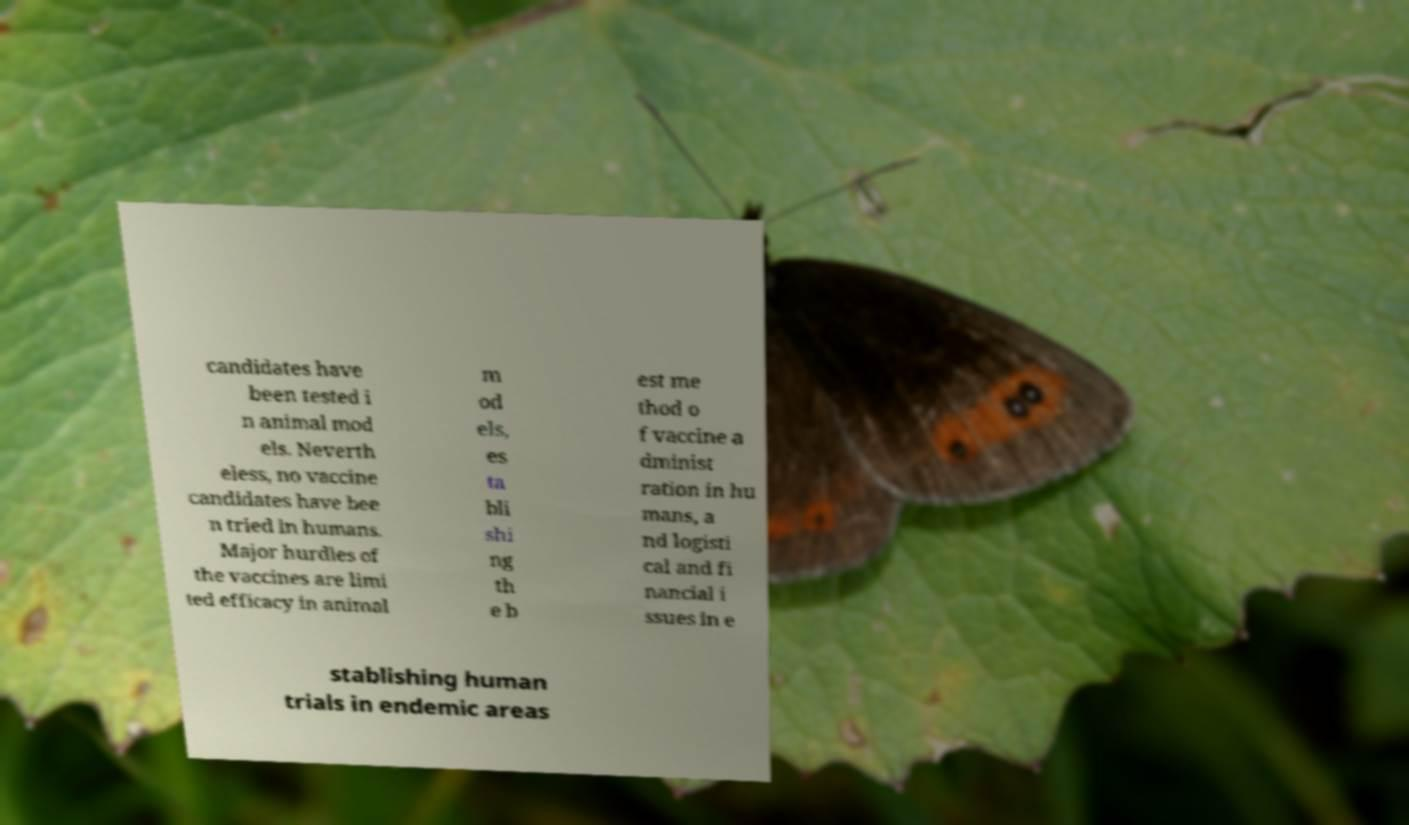For documentation purposes, I need the text within this image transcribed. Could you provide that? candidates have been tested i n animal mod els. Neverth eless, no vaccine candidates have bee n tried in humans. Major hurdles of the vaccines are limi ted efficacy in animal m od els, es ta bli shi ng th e b est me thod o f vaccine a dminist ration in hu mans, a nd logisti cal and fi nancial i ssues in e stablishing human trials in endemic areas 